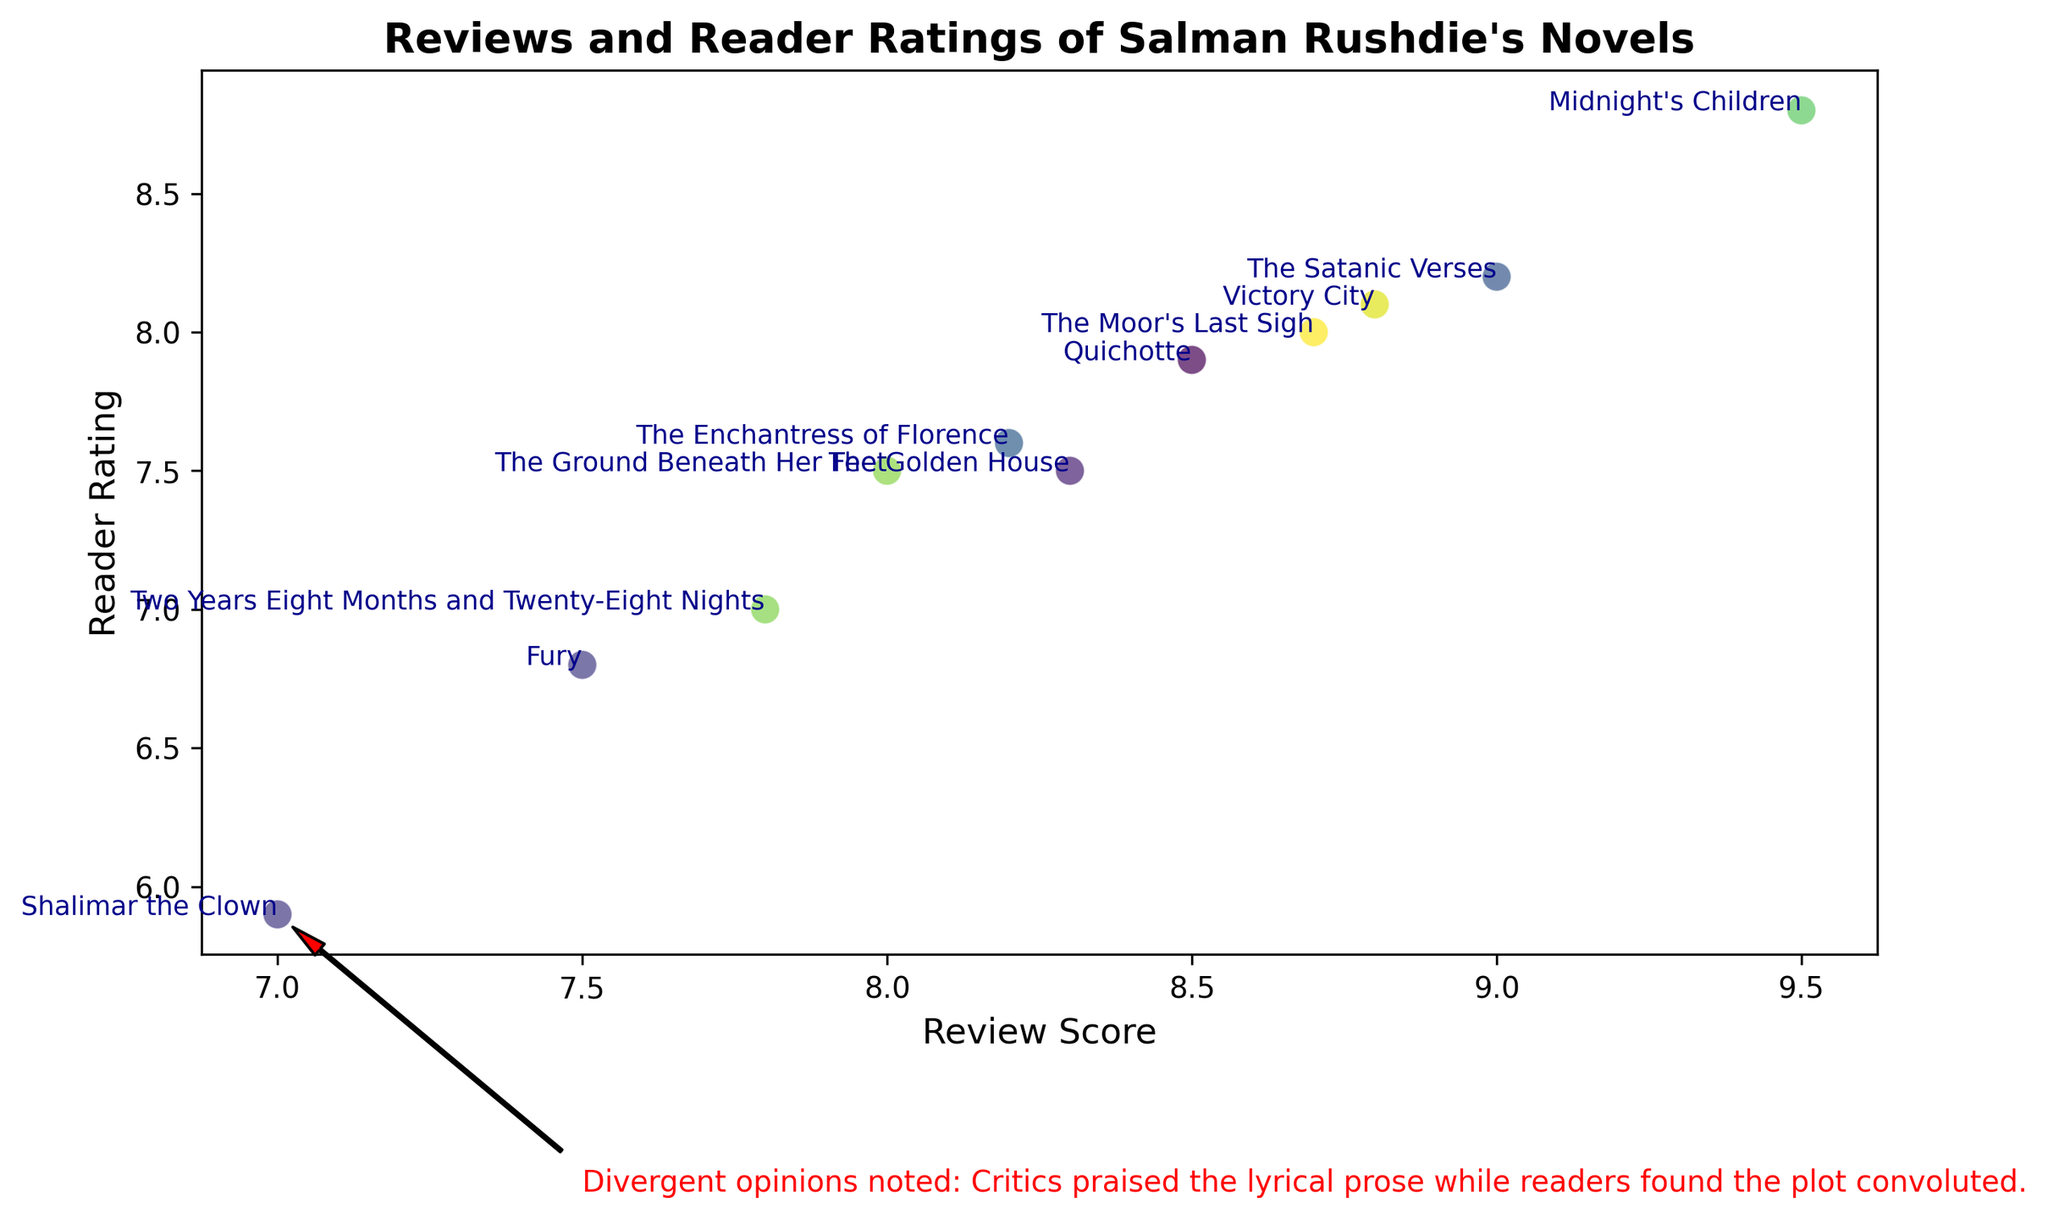What's the reader rating for "Shalimar the Clown"? To find the reader rating for "Shalimar the Clown", locate it on the scatter plot and then read the value on the y-axis at that point.
Answer: 5.9 Which novel has the highest review score, and what is its reader rating? Identify the novel with the highest review score by looking for the point furthest to the right on the x-axis and then check the associated y-axis value for its reader rating.
Answer: Midnight's Children, 8.8 How do the review scores for "The Satanic Verses" and "Shalimar the Clown" compare? Find the x-axis positions for "The Satanic Verses" and "Shalimar the Clown" and compare their x-values.
Answer: The Satanic Verses has a higher review score What is the difference between the review score and reader rating for "Victory City"? Locate "Victory City" on the scatter plot, note its review score (x-axis) and reader rating (y-axis), then calculate the difference between these two values.
Answer: 0.7 Which novels have reader ratings between 7.0 and 8.0? Find the points on the scatter plot where the y-axis values fall between 7.0 and 8.0, then check the corresponding novels.
Answer: The Moor's Last Sigh, The Ground Beneath Her Feet, The Enchantress of Florence, Two Years Eight Months and Twenty-Eight Nights, Quichotte, Victory City What is the average review score of the novels with reader ratings greater than 8? Identify the novels with reader ratings above 8 on the y-axis, then calculate the average review score (x-axis) of these novels. This involves summing their review scores and dividing by the number of such novels.
Answer: (9.5 + 9.0 + 8.7 + 8.8) / 4 = 9.0 Which novel has a significant annotation about divergent opinions, and what does it say? Look for the point with a text annotation on the scatter plot and note which novel it belongs to and what the text says.
Answer: Shalimar the Clown, "Divergent opinions noted: Critics praised the lyrical prose while readers found the plot convoluted." Of the novels marked on the plot, which has the smallest difference of review score and reader rating? Calculate the difference between review score and reader rating for each novel on the plot, then identify the novel with the smallest difference.
Answer: The Ground Beneath Her Feet, 0.5 Is there a trend between the review scores and reader ratings for Rushdie's novels? Observe the general direction of the points on the scatter plot. Determine if there is a positive, negative, or no correlation between review scores and reader ratings.
Answer: There is a generally positive trend 